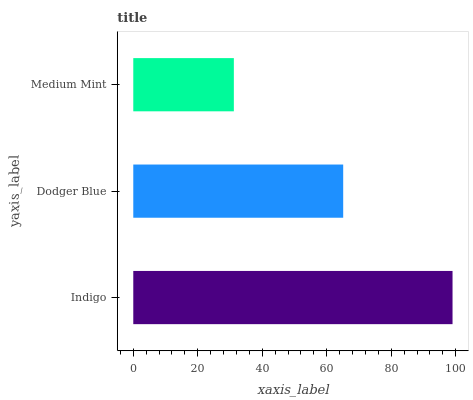Is Medium Mint the minimum?
Answer yes or no. Yes. Is Indigo the maximum?
Answer yes or no. Yes. Is Dodger Blue the minimum?
Answer yes or no. No. Is Dodger Blue the maximum?
Answer yes or no. No. Is Indigo greater than Dodger Blue?
Answer yes or no. Yes. Is Dodger Blue less than Indigo?
Answer yes or no. Yes. Is Dodger Blue greater than Indigo?
Answer yes or no. No. Is Indigo less than Dodger Blue?
Answer yes or no. No. Is Dodger Blue the high median?
Answer yes or no. Yes. Is Dodger Blue the low median?
Answer yes or no. Yes. Is Medium Mint the high median?
Answer yes or no. No. Is Medium Mint the low median?
Answer yes or no. No. 